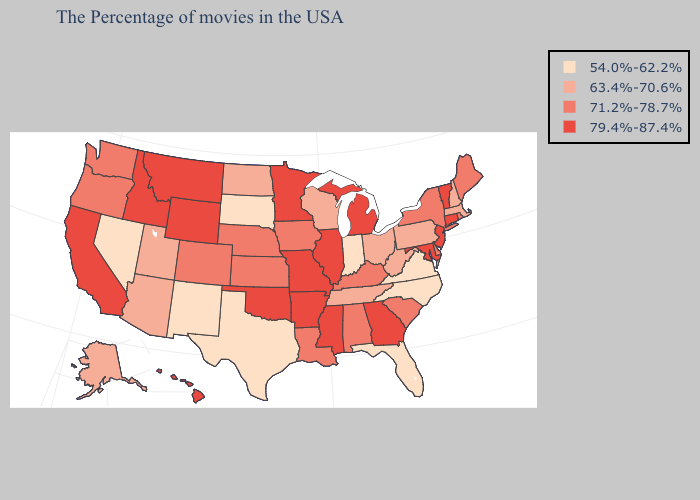What is the lowest value in states that border Michigan?
Be succinct. 54.0%-62.2%. What is the lowest value in the USA?
Answer briefly. 54.0%-62.2%. What is the highest value in the USA?
Answer briefly. 79.4%-87.4%. Does New Mexico have the same value as Indiana?
Be succinct. Yes. Name the states that have a value in the range 54.0%-62.2%?
Short answer required. Virginia, North Carolina, Florida, Indiana, Texas, South Dakota, New Mexico, Nevada. Does the first symbol in the legend represent the smallest category?
Keep it brief. Yes. Among the states that border Vermont , does New York have the highest value?
Give a very brief answer. Yes. What is the value of Indiana?
Quick response, please. 54.0%-62.2%. What is the value of Nebraska?
Give a very brief answer. 71.2%-78.7%. Does Michigan have the highest value in the USA?
Short answer required. Yes. Which states have the highest value in the USA?
Give a very brief answer. Vermont, Connecticut, New Jersey, Maryland, Georgia, Michigan, Illinois, Mississippi, Missouri, Arkansas, Minnesota, Oklahoma, Wyoming, Montana, Idaho, California, Hawaii. What is the value of Tennessee?
Write a very short answer. 63.4%-70.6%. Does the first symbol in the legend represent the smallest category?
Short answer required. Yes. Does the map have missing data?
Short answer required. No. Name the states that have a value in the range 54.0%-62.2%?
Be succinct. Virginia, North Carolina, Florida, Indiana, Texas, South Dakota, New Mexico, Nevada. 